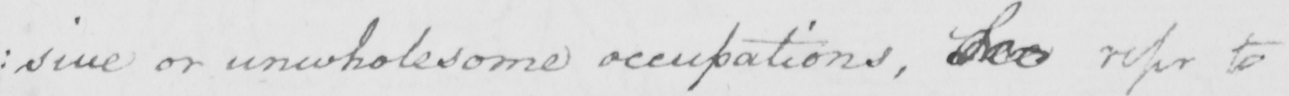Please provide the text content of this handwritten line. : sive or unwholesome occupations , See refer to 